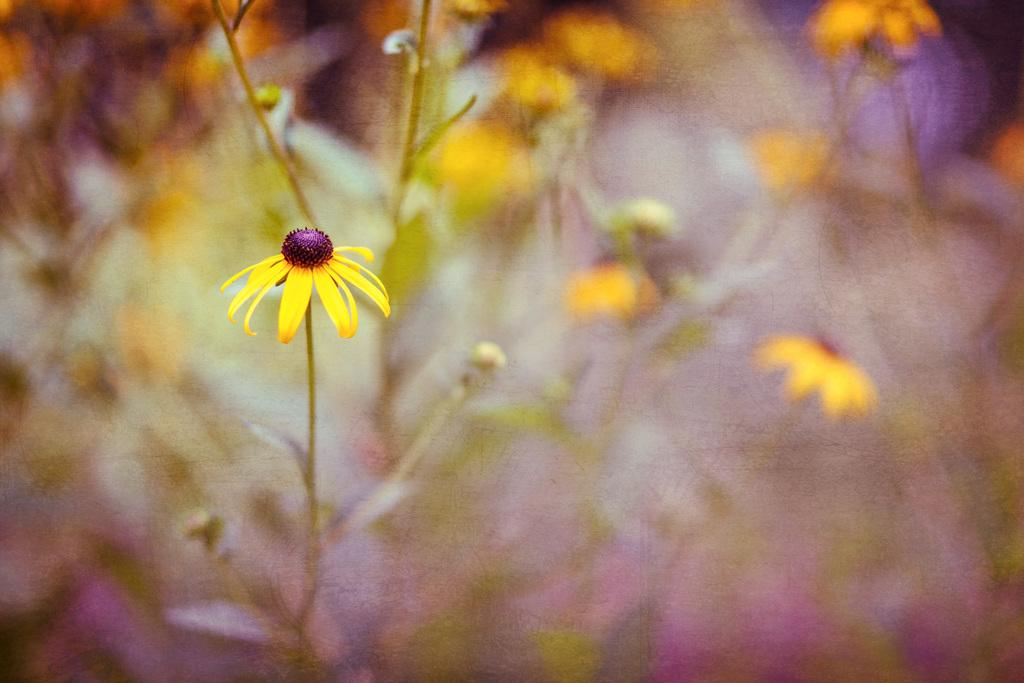What type of living organisms can be seen in the image? There are flowers in the image. What type of cave can be seen in the background of the image? There is no cave present in the image; it only features flowers. 